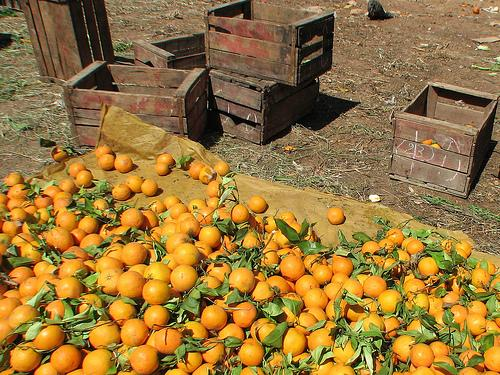What are the key elements and textures shown in the picture? Wooden crates with markings, ripe oranges, green leaves, grass, dirt ground, and brown paper are the key elements with various textures. Please provide a brief description of the scene depicted in the image. Several wooden crates with markings are placed on a dirt ground surrounded by oranges, green leaves, grass, and brown paper. Summarize the content of the image in one sentence. The image showcases an arrangement of wooden crates, oranges, leaves, and grass on a dirt ground with patches of brown paper. Provide a detailed description of the image focusing on the fruits. There are multiple ripe oranges scattered around and inside the wooden crates, some with green leaves attached, all laying on a dirt ground with grass and brown paper. Create a haiku describing the image. Nature's riches found Mention the primary objects present in the image. Wooden crates, oranges, green leaves, brown paper, and dirt ground are the main objects in this image. Tell a story about the picture in one sentence. Upon stumbling into a secluded orchard, an array of wooden crates laden with sun-warmed oranges amid a blanket of leaves and grass catches the curious eyes of passersby. Describe the objects in the picture and their relation to each other. There are wooden crates containing and surrounded by ripe oranges, with green leaves and patches of grass scattered on the dirt ground. Describe the setting and the objects in the image using a poetic language. Amidst the rustic embrace of sprawling greenery and earthen terrain, lie crates etched with enigmatic markings, cradling sun-kissed orbs of ripened oranges. What are the primary colors and elements in the image? Predominant colors are brown from the crates and dirt ground, orange from the fruit, and green from the leaves and grass. 